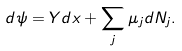<formula> <loc_0><loc_0><loc_500><loc_500>d \psi = Y d x + \sum _ { j } \mu _ { j } d N _ { j } .</formula> 